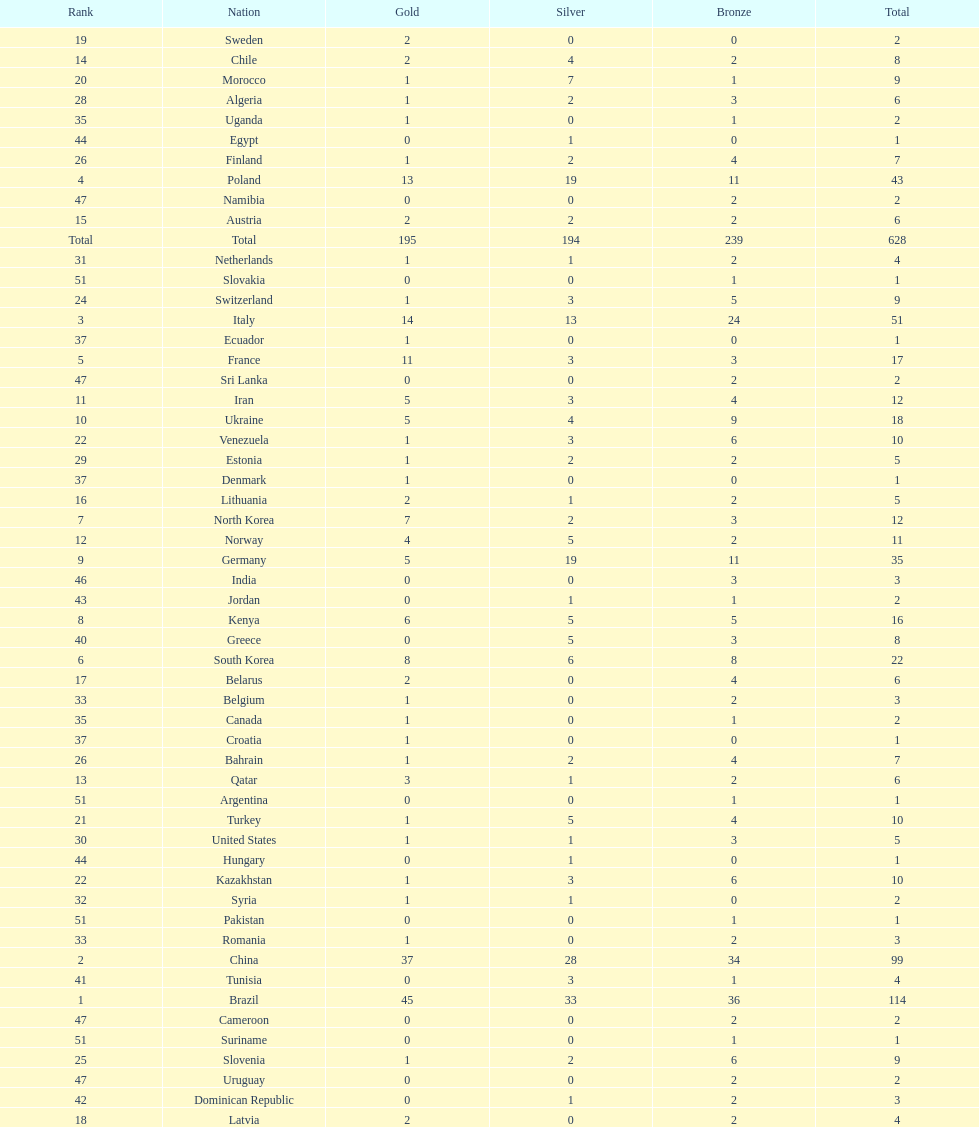Who won more gold medals, brazil or china? Brazil. 